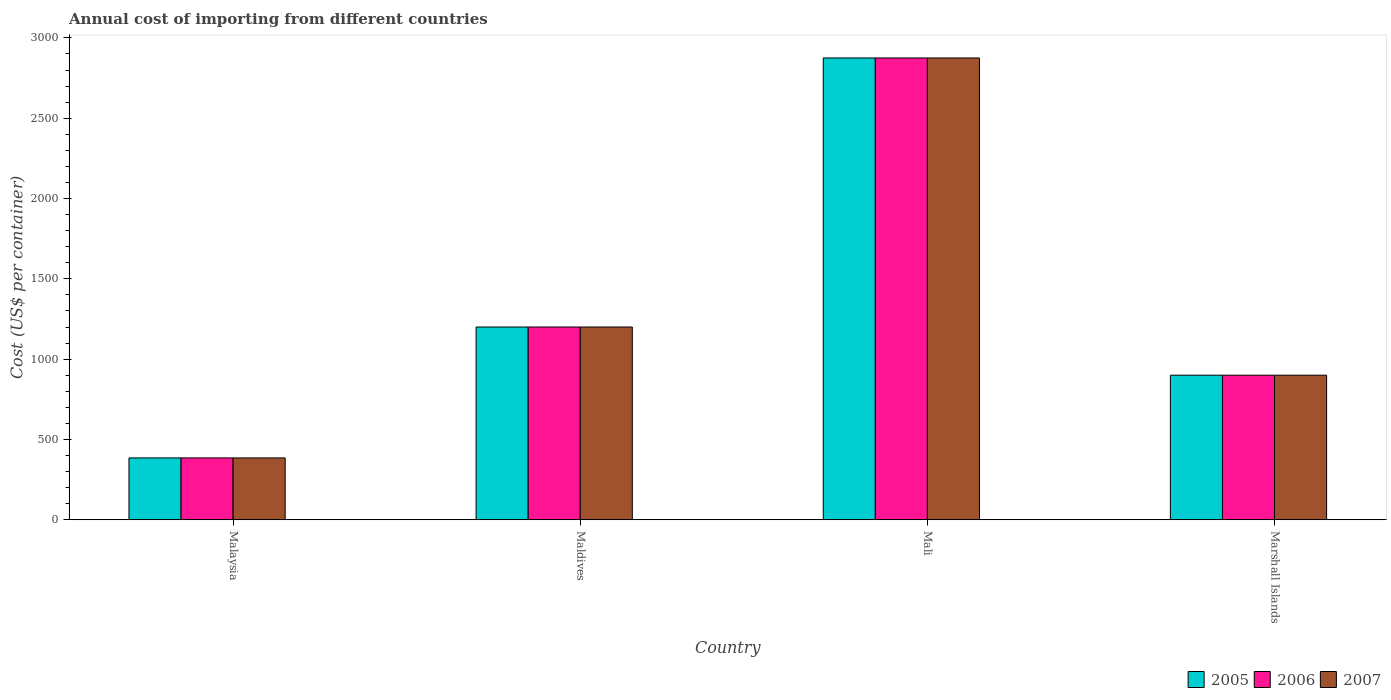How many different coloured bars are there?
Your response must be concise. 3. How many groups of bars are there?
Your answer should be compact. 4. Are the number of bars on each tick of the X-axis equal?
Your answer should be very brief. Yes. What is the label of the 4th group of bars from the left?
Your response must be concise. Marshall Islands. What is the total annual cost of importing in 2005 in Maldives?
Your answer should be compact. 1200. Across all countries, what is the maximum total annual cost of importing in 2007?
Offer a terse response. 2875. Across all countries, what is the minimum total annual cost of importing in 2006?
Offer a very short reply. 385. In which country was the total annual cost of importing in 2006 maximum?
Provide a short and direct response. Mali. In which country was the total annual cost of importing in 2006 minimum?
Give a very brief answer. Malaysia. What is the total total annual cost of importing in 2006 in the graph?
Keep it short and to the point. 5360. What is the difference between the total annual cost of importing in 2005 in Mali and that in Marshall Islands?
Provide a short and direct response. 1975. What is the difference between the total annual cost of importing in 2007 in Malaysia and the total annual cost of importing in 2005 in Marshall Islands?
Provide a succinct answer. -515. What is the average total annual cost of importing in 2006 per country?
Provide a short and direct response. 1340. In how many countries, is the total annual cost of importing in 2005 greater than 2500 US$?
Provide a short and direct response. 1. What is the ratio of the total annual cost of importing in 2007 in Malaysia to that in Maldives?
Offer a very short reply. 0.32. Is the total annual cost of importing in 2006 in Mali less than that in Marshall Islands?
Provide a succinct answer. No. What is the difference between the highest and the second highest total annual cost of importing in 2006?
Offer a very short reply. -1675. What is the difference between the highest and the lowest total annual cost of importing in 2007?
Make the answer very short. 2490. Is the sum of the total annual cost of importing in 2005 in Maldives and Marshall Islands greater than the maximum total annual cost of importing in 2007 across all countries?
Make the answer very short. No. What does the 1st bar from the left in Mali represents?
Offer a terse response. 2005. Is it the case that in every country, the sum of the total annual cost of importing in 2007 and total annual cost of importing in 2005 is greater than the total annual cost of importing in 2006?
Provide a succinct answer. Yes. Are all the bars in the graph horizontal?
Offer a very short reply. No. How many countries are there in the graph?
Provide a short and direct response. 4. What is the difference between two consecutive major ticks on the Y-axis?
Provide a succinct answer. 500. Does the graph contain any zero values?
Keep it short and to the point. No. Where does the legend appear in the graph?
Ensure brevity in your answer.  Bottom right. How are the legend labels stacked?
Your response must be concise. Horizontal. What is the title of the graph?
Give a very brief answer. Annual cost of importing from different countries. What is the label or title of the Y-axis?
Your answer should be very brief. Cost (US$ per container). What is the Cost (US$ per container) in 2005 in Malaysia?
Make the answer very short. 385. What is the Cost (US$ per container) of 2006 in Malaysia?
Make the answer very short. 385. What is the Cost (US$ per container) of 2007 in Malaysia?
Provide a short and direct response. 385. What is the Cost (US$ per container) in 2005 in Maldives?
Make the answer very short. 1200. What is the Cost (US$ per container) of 2006 in Maldives?
Your answer should be very brief. 1200. What is the Cost (US$ per container) in 2007 in Maldives?
Offer a terse response. 1200. What is the Cost (US$ per container) in 2005 in Mali?
Your answer should be very brief. 2875. What is the Cost (US$ per container) in 2006 in Mali?
Offer a very short reply. 2875. What is the Cost (US$ per container) in 2007 in Mali?
Give a very brief answer. 2875. What is the Cost (US$ per container) of 2005 in Marshall Islands?
Give a very brief answer. 900. What is the Cost (US$ per container) in 2006 in Marshall Islands?
Provide a short and direct response. 900. What is the Cost (US$ per container) of 2007 in Marshall Islands?
Offer a very short reply. 900. Across all countries, what is the maximum Cost (US$ per container) of 2005?
Offer a terse response. 2875. Across all countries, what is the maximum Cost (US$ per container) of 2006?
Your answer should be compact. 2875. Across all countries, what is the maximum Cost (US$ per container) in 2007?
Ensure brevity in your answer.  2875. Across all countries, what is the minimum Cost (US$ per container) in 2005?
Provide a short and direct response. 385. Across all countries, what is the minimum Cost (US$ per container) in 2006?
Your answer should be compact. 385. Across all countries, what is the minimum Cost (US$ per container) of 2007?
Give a very brief answer. 385. What is the total Cost (US$ per container) of 2005 in the graph?
Provide a succinct answer. 5360. What is the total Cost (US$ per container) of 2006 in the graph?
Offer a very short reply. 5360. What is the total Cost (US$ per container) in 2007 in the graph?
Give a very brief answer. 5360. What is the difference between the Cost (US$ per container) in 2005 in Malaysia and that in Maldives?
Give a very brief answer. -815. What is the difference between the Cost (US$ per container) of 2006 in Malaysia and that in Maldives?
Your response must be concise. -815. What is the difference between the Cost (US$ per container) in 2007 in Malaysia and that in Maldives?
Ensure brevity in your answer.  -815. What is the difference between the Cost (US$ per container) of 2005 in Malaysia and that in Mali?
Your answer should be compact. -2490. What is the difference between the Cost (US$ per container) in 2006 in Malaysia and that in Mali?
Ensure brevity in your answer.  -2490. What is the difference between the Cost (US$ per container) of 2007 in Malaysia and that in Mali?
Offer a terse response. -2490. What is the difference between the Cost (US$ per container) of 2005 in Malaysia and that in Marshall Islands?
Ensure brevity in your answer.  -515. What is the difference between the Cost (US$ per container) of 2006 in Malaysia and that in Marshall Islands?
Offer a very short reply. -515. What is the difference between the Cost (US$ per container) of 2007 in Malaysia and that in Marshall Islands?
Offer a very short reply. -515. What is the difference between the Cost (US$ per container) of 2005 in Maldives and that in Mali?
Provide a short and direct response. -1675. What is the difference between the Cost (US$ per container) in 2006 in Maldives and that in Mali?
Offer a terse response. -1675. What is the difference between the Cost (US$ per container) of 2007 in Maldives and that in Mali?
Your answer should be compact. -1675. What is the difference between the Cost (US$ per container) in 2005 in Maldives and that in Marshall Islands?
Ensure brevity in your answer.  300. What is the difference between the Cost (US$ per container) in 2006 in Maldives and that in Marshall Islands?
Your answer should be compact. 300. What is the difference between the Cost (US$ per container) of 2007 in Maldives and that in Marshall Islands?
Keep it short and to the point. 300. What is the difference between the Cost (US$ per container) of 2005 in Mali and that in Marshall Islands?
Your answer should be compact. 1975. What is the difference between the Cost (US$ per container) in 2006 in Mali and that in Marshall Islands?
Ensure brevity in your answer.  1975. What is the difference between the Cost (US$ per container) in 2007 in Mali and that in Marshall Islands?
Your answer should be very brief. 1975. What is the difference between the Cost (US$ per container) of 2005 in Malaysia and the Cost (US$ per container) of 2006 in Maldives?
Your response must be concise. -815. What is the difference between the Cost (US$ per container) of 2005 in Malaysia and the Cost (US$ per container) of 2007 in Maldives?
Your answer should be very brief. -815. What is the difference between the Cost (US$ per container) of 2006 in Malaysia and the Cost (US$ per container) of 2007 in Maldives?
Give a very brief answer. -815. What is the difference between the Cost (US$ per container) of 2005 in Malaysia and the Cost (US$ per container) of 2006 in Mali?
Your answer should be compact. -2490. What is the difference between the Cost (US$ per container) of 2005 in Malaysia and the Cost (US$ per container) of 2007 in Mali?
Offer a terse response. -2490. What is the difference between the Cost (US$ per container) of 2006 in Malaysia and the Cost (US$ per container) of 2007 in Mali?
Your response must be concise. -2490. What is the difference between the Cost (US$ per container) in 2005 in Malaysia and the Cost (US$ per container) in 2006 in Marshall Islands?
Keep it short and to the point. -515. What is the difference between the Cost (US$ per container) of 2005 in Malaysia and the Cost (US$ per container) of 2007 in Marshall Islands?
Keep it short and to the point. -515. What is the difference between the Cost (US$ per container) of 2006 in Malaysia and the Cost (US$ per container) of 2007 in Marshall Islands?
Your answer should be compact. -515. What is the difference between the Cost (US$ per container) in 2005 in Maldives and the Cost (US$ per container) in 2006 in Mali?
Keep it short and to the point. -1675. What is the difference between the Cost (US$ per container) in 2005 in Maldives and the Cost (US$ per container) in 2007 in Mali?
Keep it short and to the point. -1675. What is the difference between the Cost (US$ per container) in 2006 in Maldives and the Cost (US$ per container) in 2007 in Mali?
Make the answer very short. -1675. What is the difference between the Cost (US$ per container) in 2005 in Maldives and the Cost (US$ per container) in 2006 in Marshall Islands?
Ensure brevity in your answer.  300. What is the difference between the Cost (US$ per container) in 2005 in Maldives and the Cost (US$ per container) in 2007 in Marshall Islands?
Your response must be concise. 300. What is the difference between the Cost (US$ per container) in 2006 in Maldives and the Cost (US$ per container) in 2007 in Marshall Islands?
Keep it short and to the point. 300. What is the difference between the Cost (US$ per container) of 2005 in Mali and the Cost (US$ per container) of 2006 in Marshall Islands?
Ensure brevity in your answer.  1975. What is the difference between the Cost (US$ per container) of 2005 in Mali and the Cost (US$ per container) of 2007 in Marshall Islands?
Ensure brevity in your answer.  1975. What is the difference between the Cost (US$ per container) in 2006 in Mali and the Cost (US$ per container) in 2007 in Marshall Islands?
Your answer should be very brief. 1975. What is the average Cost (US$ per container) of 2005 per country?
Offer a terse response. 1340. What is the average Cost (US$ per container) of 2006 per country?
Offer a very short reply. 1340. What is the average Cost (US$ per container) in 2007 per country?
Offer a very short reply. 1340. What is the difference between the Cost (US$ per container) in 2006 and Cost (US$ per container) in 2007 in Malaysia?
Your response must be concise. 0. What is the difference between the Cost (US$ per container) in 2005 and Cost (US$ per container) in 2006 in Maldives?
Provide a short and direct response. 0. What is the difference between the Cost (US$ per container) of 2005 and Cost (US$ per container) of 2007 in Maldives?
Provide a succinct answer. 0. What is the difference between the Cost (US$ per container) in 2006 and Cost (US$ per container) in 2007 in Maldives?
Give a very brief answer. 0. What is the difference between the Cost (US$ per container) in 2005 and Cost (US$ per container) in 2007 in Mali?
Provide a succinct answer. 0. What is the difference between the Cost (US$ per container) in 2005 and Cost (US$ per container) in 2007 in Marshall Islands?
Keep it short and to the point. 0. What is the ratio of the Cost (US$ per container) of 2005 in Malaysia to that in Maldives?
Keep it short and to the point. 0.32. What is the ratio of the Cost (US$ per container) of 2006 in Malaysia to that in Maldives?
Keep it short and to the point. 0.32. What is the ratio of the Cost (US$ per container) of 2007 in Malaysia to that in Maldives?
Your answer should be compact. 0.32. What is the ratio of the Cost (US$ per container) in 2005 in Malaysia to that in Mali?
Ensure brevity in your answer.  0.13. What is the ratio of the Cost (US$ per container) in 2006 in Malaysia to that in Mali?
Offer a very short reply. 0.13. What is the ratio of the Cost (US$ per container) of 2007 in Malaysia to that in Mali?
Provide a succinct answer. 0.13. What is the ratio of the Cost (US$ per container) in 2005 in Malaysia to that in Marshall Islands?
Offer a very short reply. 0.43. What is the ratio of the Cost (US$ per container) of 2006 in Malaysia to that in Marshall Islands?
Keep it short and to the point. 0.43. What is the ratio of the Cost (US$ per container) of 2007 in Malaysia to that in Marshall Islands?
Your answer should be very brief. 0.43. What is the ratio of the Cost (US$ per container) of 2005 in Maldives to that in Mali?
Provide a short and direct response. 0.42. What is the ratio of the Cost (US$ per container) of 2006 in Maldives to that in Mali?
Ensure brevity in your answer.  0.42. What is the ratio of the Cost (US$ per container) in 2007 in Maldives to that in Mali?
Give a very brief answer. 0.42. What is the ratio of the Cost (US$ per container) of 2005 in Maldives to that in Marshall Islands?
Provide a succinct answer. 1.33. What is the ratio of the Cost (US$ per container) of 2005 in Mali to that in Marshall Islands?
Your response must be concise. 3.19. What is the ratio of the Cost (US$ per container) of 2006 in Mali to that in Marshall Islands?
Provide a short and direct response. 3.19. What is the ratio of the Cost (US$ per container) of 2007 in Mali to that in Marshall Islands?
Keep it short and to the point. 3.19. What is the difference between the highest and the second highest Cost (US$ per container) in 2005?
Ensure brevity in your answer.  1675. What is the difference between the highest and the second highest Cost (US$ per container) in 2006?
Your answer should be compact. 1675. What is the difference between the highest and the second highest Cost (US$ per container) of 2007?
Your response must be concise. 1675. What is the difference between the highest and the lowest Cost (US$ per container) in 2005?
Provide a succinct answer. 2490. What is the difference between the highest and the lowest Cost (US$ per container) in 2006?
Your response must be concise. 2490. What is the difference between the highest and the lowest Cost (US$ per container) of 2007?
Provide a short and direct response. 2490. 